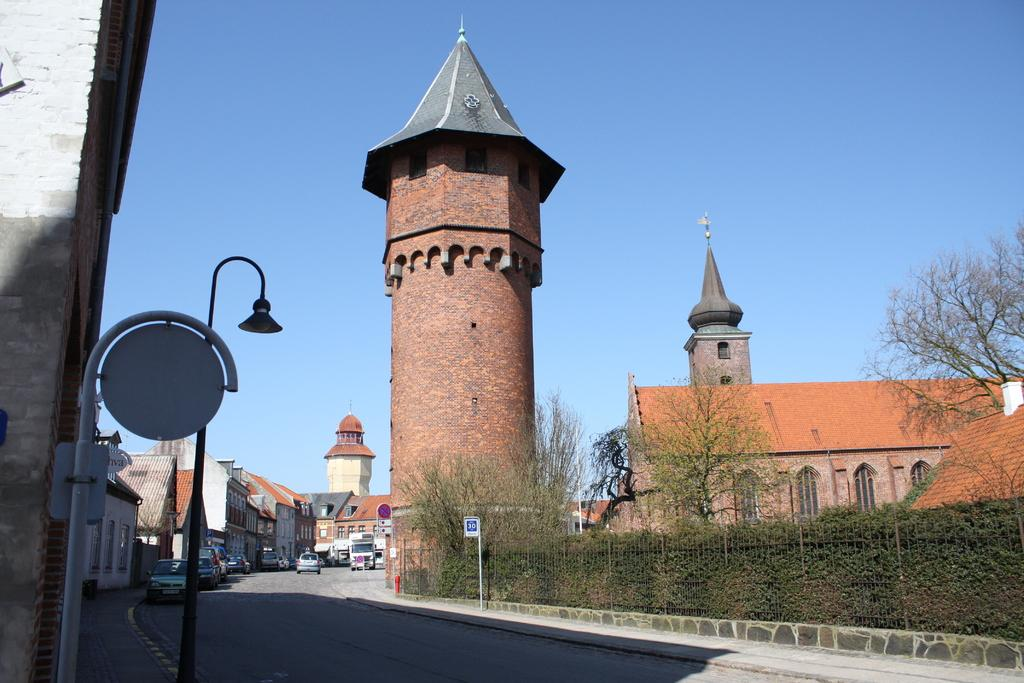What type of structures can be seen in the image? There are buildings in the image. What is present on the road in the image? There are vehicles on the road in the image. What can be seen providing information or directions in the image? There are sign boards in the image. What is the tall, vertical object near the buildings in the image? There is a light pole in the image. What type of vegetation is present in the image? There are plants and trees in the image. What type of barrier can be seen in the image? There is a fencing in the image. What part of the natural environment is visible in the image? The sky is visible in the image. How many cakes are displayed on the sign boards in the image? There are no cakes present on the sign boards in the image. What season is depicted in the image, considering the presence of spring flowers? There is no indication of a specific season in the image, as it does not show any flowers or other seasonal elements. 